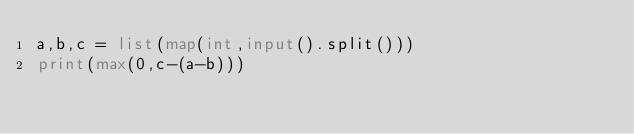Convert code to text. <code><loc_0><loc_0><loc_500><loc_500><_Python_>a,b,c = list(map(int,input().split()))
print(max(0,c-(a-b)))</code> 